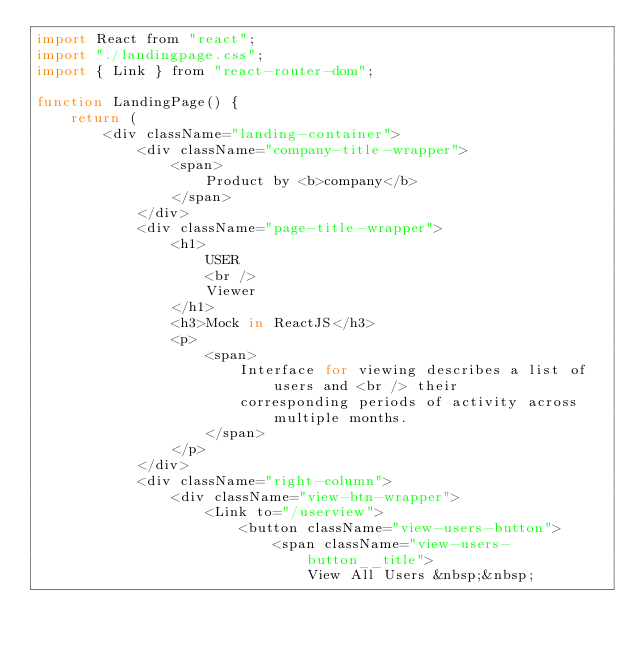Convert code to text. <code><loc_0><loc_0><loc_500><loc_500><_JavaScript_>import React from "react";
import "./landingpage.css";
import { Link } from "react-router-dom";

function LandingPage() {
	return (
		<div className="landing-container">
			<div className="company-title-wrapper">
				<span>
					Product by <b>company</b>
				</span>
			</div>
			<div className="page-title-wrapper">
				<h1>
					USER
					<br />
					Viewer
				</h1>
				<h3>Mock in ReactJS</h3>
				<p>
					<span>
						Interface for viewing describes a list of users and <br /> their
						corresponding periods of activity across multiple months.
					</span>
				</p>
			</div>
			<div className="right-column">
				<div className="view-btn-wrapper">
					<Link to="/userview">
						<button className="view-users-button">
							<span className="view-users-button__title">
								View All Users &nbsp;&nbsp;</code> 